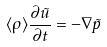Convert formula to latex. <formula><loc_0><loc_0><loc_500><loc_500>\langle \rho \rangle \frac { \partial \tilde { u } } { \partial t } = - \nabla \tilde { p }</formula> 